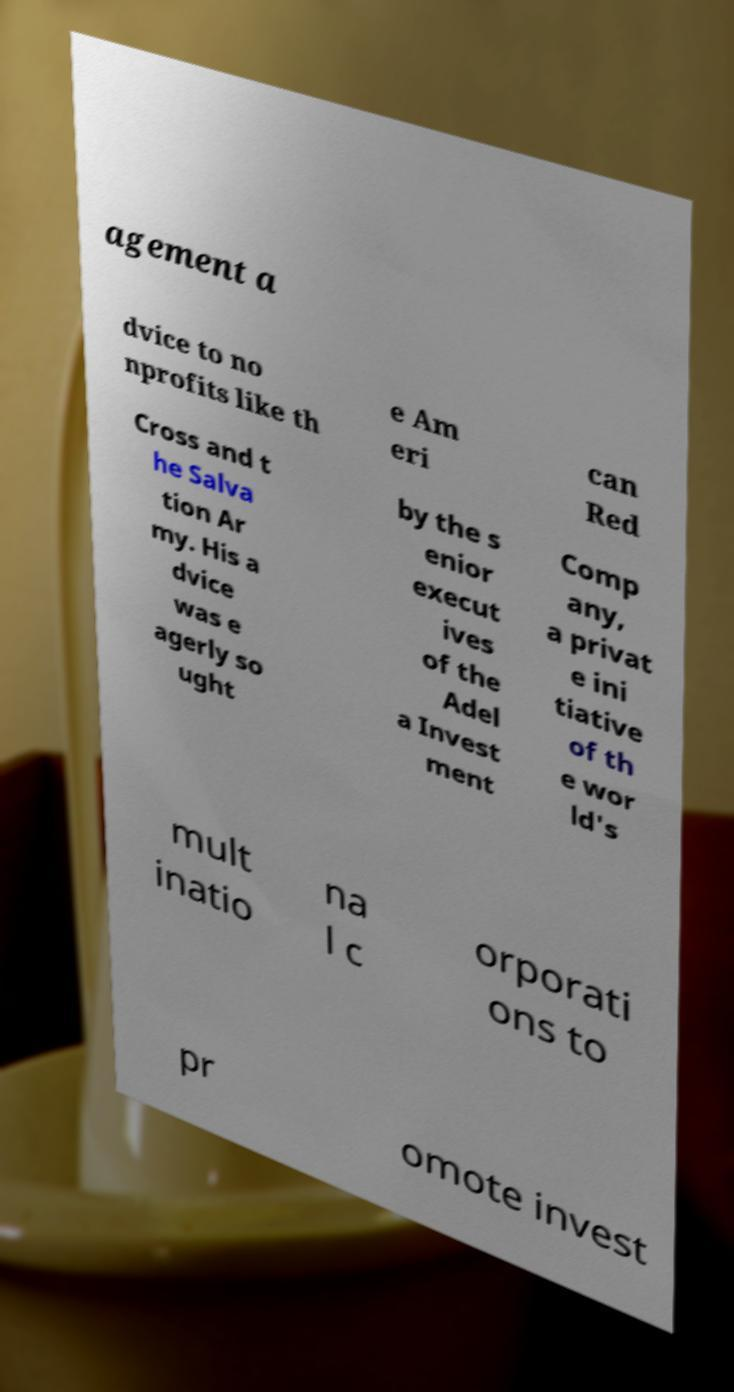There's text embedded in this image that I need extracted. Can you transcribe it verbatim? agement a dvice to no nprofits like th e Am eri can Red Cross and t he Salva tion Ar my. His a dvice was e agerly so ught by the s enior execut ives of the Adel a Invest ment Comp any, a privat e ini tiative of th e wor ld's mult inatio na l c orporati ons to pr omote invest 